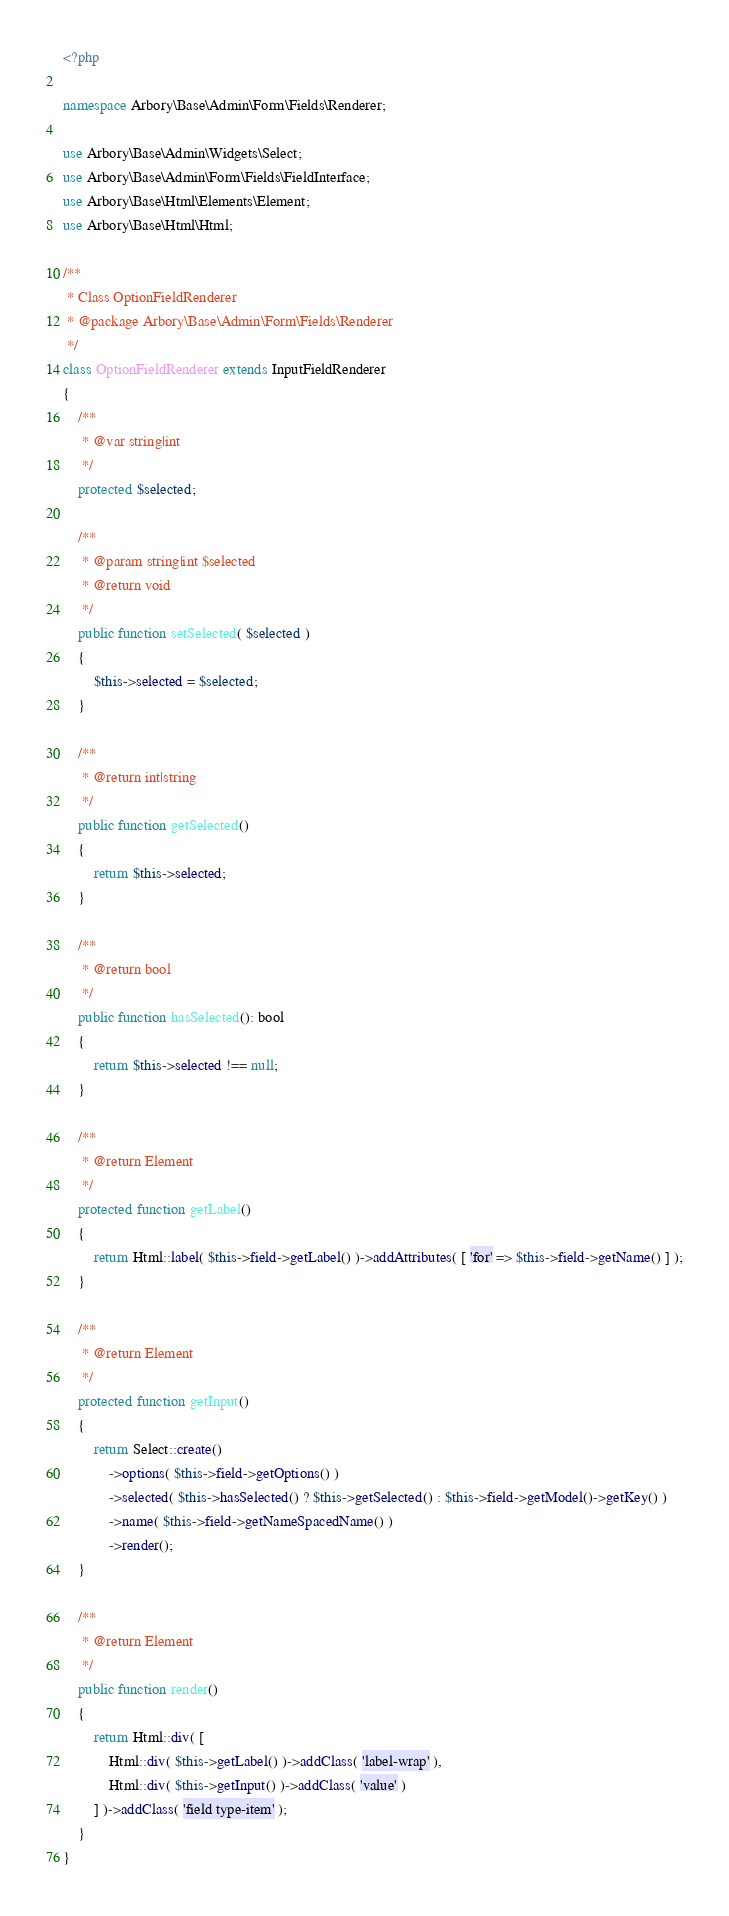<code> <loc_0><loc_0><loc_500><loc_500><_PHP_><?php

namespace Arbory\Base\Admin\Form\Fields\Renderer;

use Arbory\Base\Admin\Widgets\Select;
use Arbory\Base\Admin\Form\Fields\FieldInterface;
use Arbory\Base\Html\Elements\Element;
use Arbory\Base\Html\Html;

/**
 * Class OptionFieldRenderer
 * @package Arbory\Base\Admin\Form\Fields\Renderer
 */
class OptionFieldRenderer extends InputFieldRenderer
{
    /**
     * @var string|int
     */
    protected $selected;

    /**
     * @param string|int $selected
     * @return void
     */
    public function setSelected( $selected )
    {
        $this->selected = $selected;
    }

    /**
     * @return int|string
     */
    public function getSelected()
    {
        return $this->selected;
    }

    /**
     * @return bool
     */
    public function hasSelected(): bool
    {
        return $this->selected !== null;
    }

    /**
     * @return Element
     */
    protected function getLabel()
    {
        return Html::label( $this->field->getLabel() )->addAttributes( [ 'for' => $this->field->getName() ] );
    }

    /**
     * @return Element
     */
    protected function getInput()
    {
        return Select::create()
            ->options( $this->field->getOptions() )
            ->selected( $this->hasSelected() ? $this->getSelected() : $this->field->getModel()->getKey() )
            ->name( $this->field->getNameSpacedName() )
            ->render();
    }

    /**
     * @return Element
     */
    public function render()
    {
        return Html::div( [
            Html::div( $this->getLabel() )->addClass( 'label-wrap' ),
            Html::div( $this->getInput() )->addClass( 'value' )
        ] )->addClass( 'field type-item' );
    }
}

</code> 